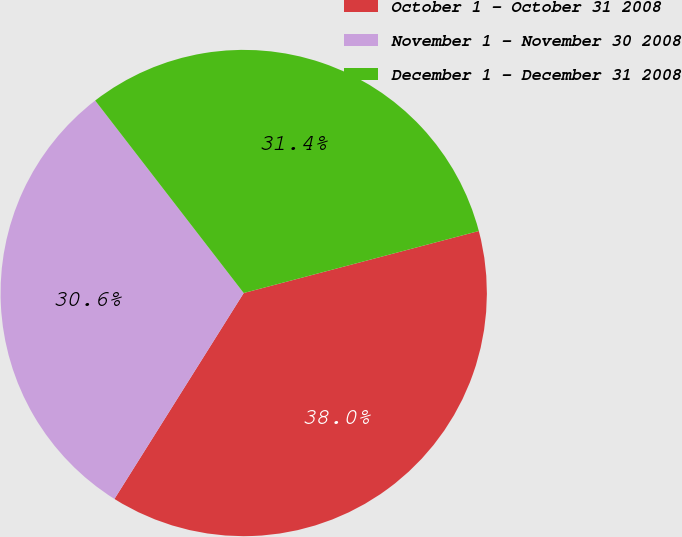Convert chart to OTSL. <chart><loc_0><loc_0><loc_500><loc_500><pie_chart><fcel>October 1 - October 31 2008<fcel>November 1 - November 30 2008<fcel>December 1 - December 31 2008<nl><fcel>38.03%<fcel>30.62%<fcel>31.36%<nl></chart> 